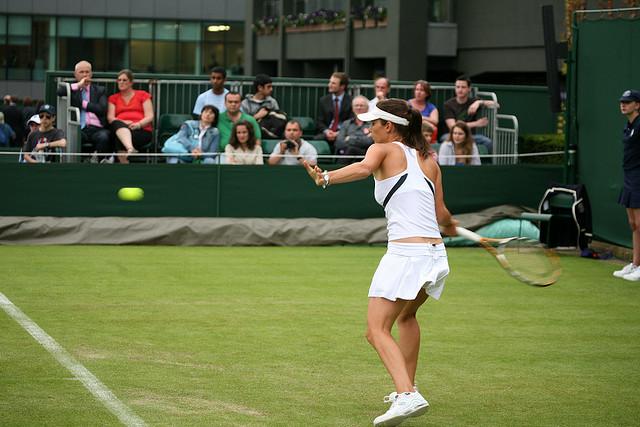Is the girl in motion?
Short answer required. Yes. Does the player look excited?
Keep it brief. No. What shot is this player executing?
Give a very brief answer. Backhand. What sport is this woman playing?
Answer briefly. Tennis. Is she playing on clay?
Give a very brief answer. No. How many people are at the event?
Concise answer only. 18. 